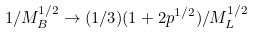<formula> <loc_0><loc_0><loc_500><loc_500>1 / M _ { B } ^ { 1 / 2 } \rightarrow ( 1 / 3 ) ( 1 + 2 p ^ { 1 / 2 } ) / M _ { L } ^ { 1 / 2 }</formula> 